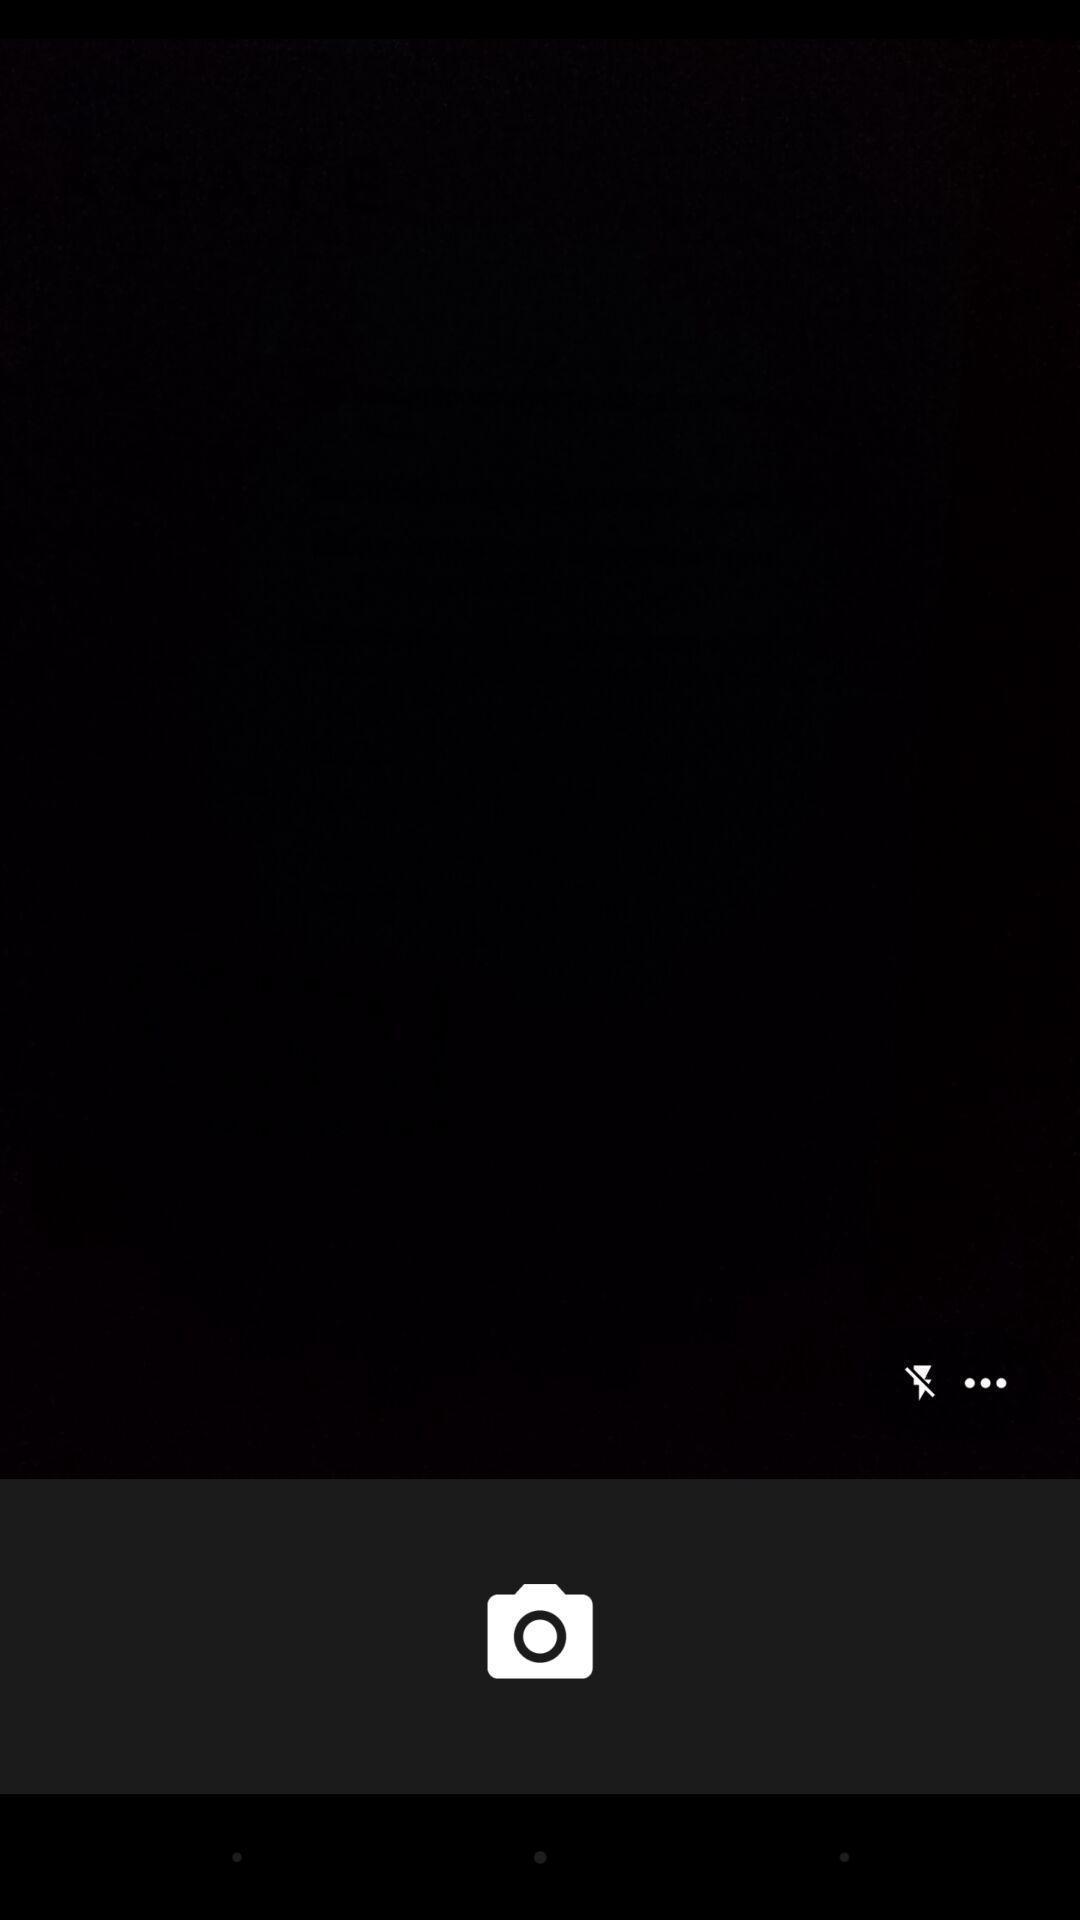Describe this image in words. Page showing camera option to capture images. 